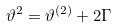Convert formula to latex. <formula><loc_0><loc_0><loc_500><loc_500>\vartheta ^ { 2 } = \vartheta ^ { ( 2 ) } + 2 \Gamma</formula> 